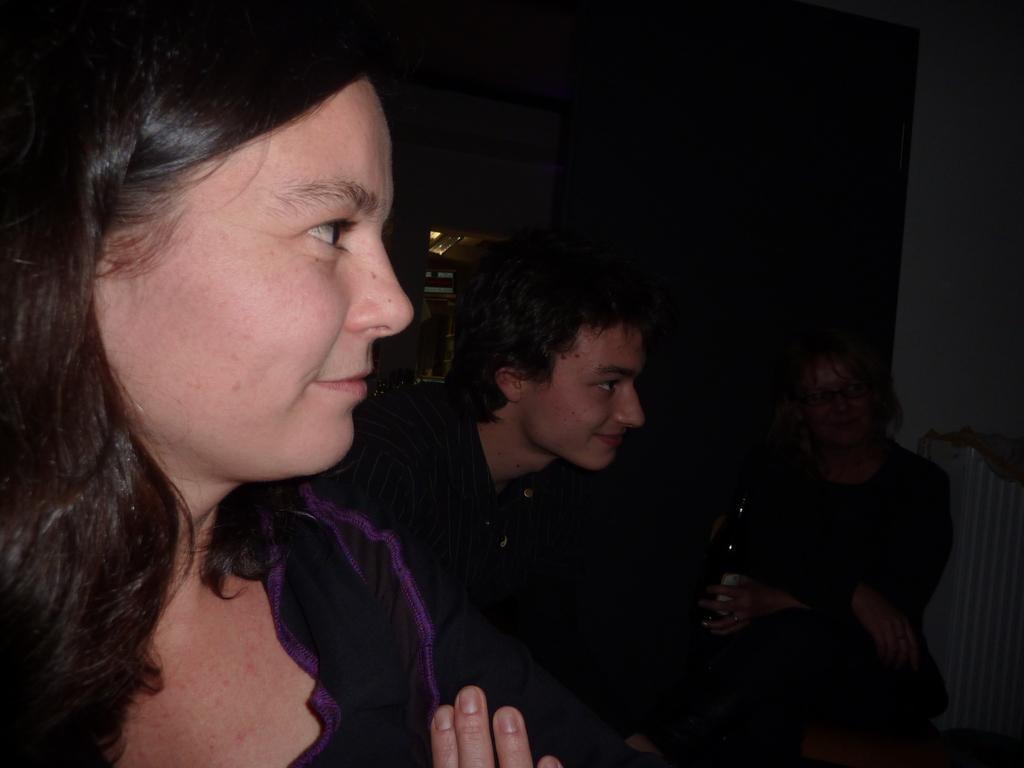Describe this image in one or two sentences. On the left side of this image there are two persons looking at the right side. In the background, I can see a person in the dark. 